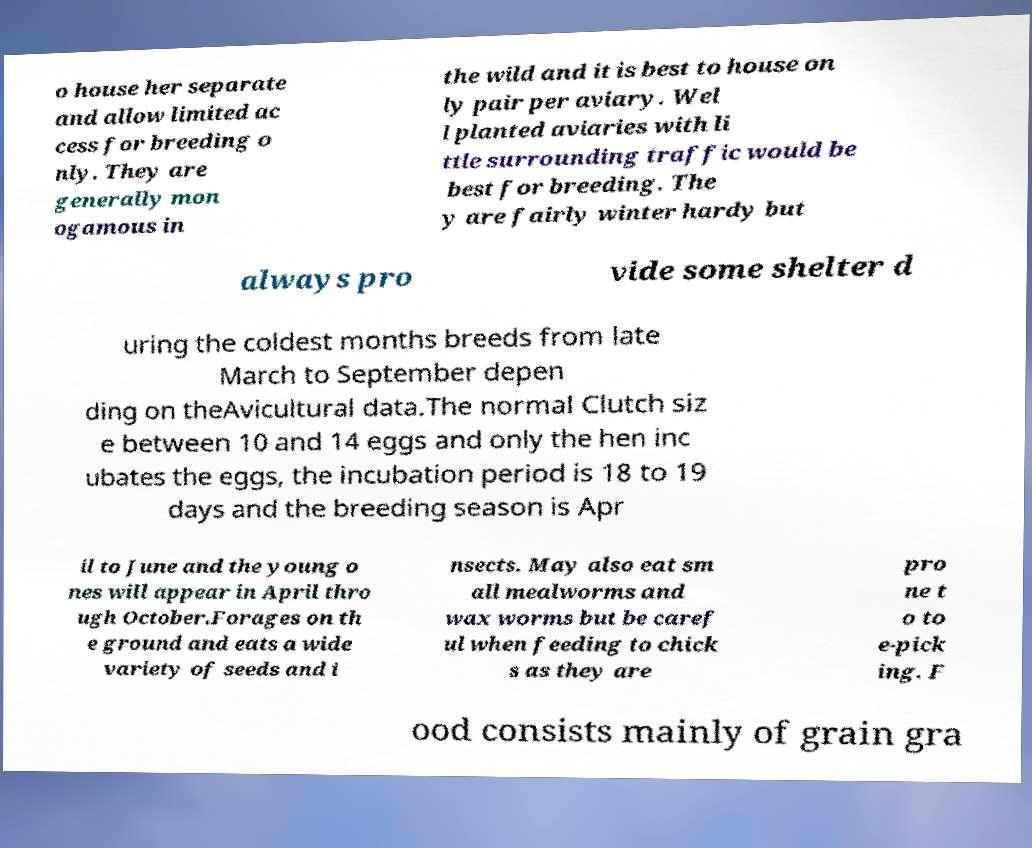I need the written content from this picture converted into text. Can you do that? o house her separate and allow limited ac cess for breeding o nly. They are generally mon ogamous in the wild and it is best to house on ly pair per aviary. Wel l planted aviaries with li ttle surrounding traffic would be best for breeding. The y are fairly winter hardy but always pro vide some shelter d uring the coldest months breeds from late March to September depen ding on theAvicultural data.The normal Clutch siz e between 10 and 14 eggs and only the hen inc ubates the eggs, the incubation period is 18 to 19 days and the breeding season is Apr il to June and the young o nes will appear in April thro ugh October.Forages on th e ground and eats a wide variety of seeds and i nsects. May also eat sm all mealworms and wax worms but be caref ul when feeding to chick s as they are pro ne t o to e-pick ing. F ood consists mainly of grain gra 